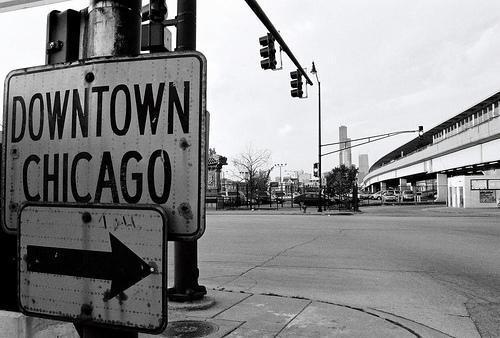How many people in the boat are wearing life jackets?
Give a very brief answer. 0. 